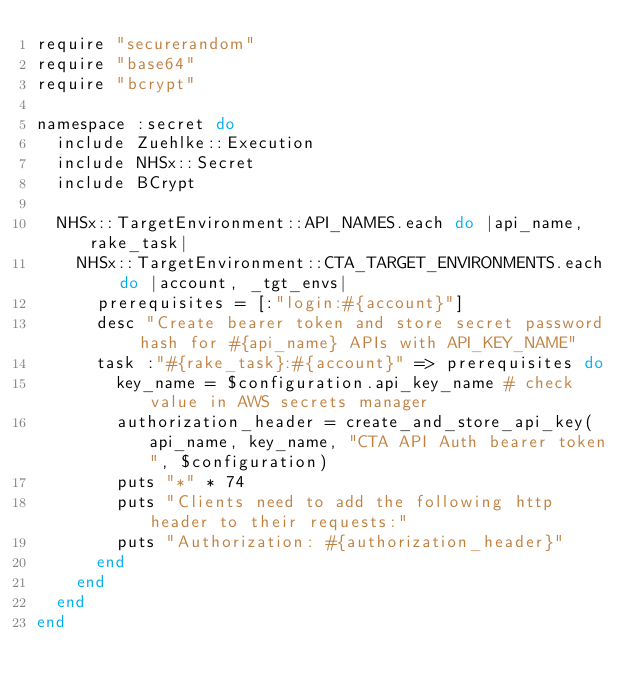<code> <loc_0><loc_0><loc_500><loc_500><_Ruby_>require "securerandom"
require "base64"
require "bcrypt"

namespace :secret do
  include Zuehlke::Execution
  include NHSx::Secret
  include BCrypt

  NHSx::TargetEnvironment::API_NAMES.each do |api_name, rake_task|
    NHSx::TargetEnvironment::CTA_TARGET_ENVIRONMENTS.each do |account, _tgt_envs|
      prerequisites = [:"login:#{account}"]
      desc "Create bearer token and store secret password hash for #{api_name} APIs with API_KEY_NAME"
      task :"#{rake_task}:#{account}" => prerequisites do
        key_name = $configuration.api_key_name # check value in AWS secrets manager
        authorization_header = create_and_store_api_key(api_name, key_name, "CTA API Auth bearer token", $configuration)
        puts "*" * 74
        puts "Clients need to add the following http header to their requests:"
        puts "Authorization: #{authorization_header}"
      end
    end
  end
end
</code> 